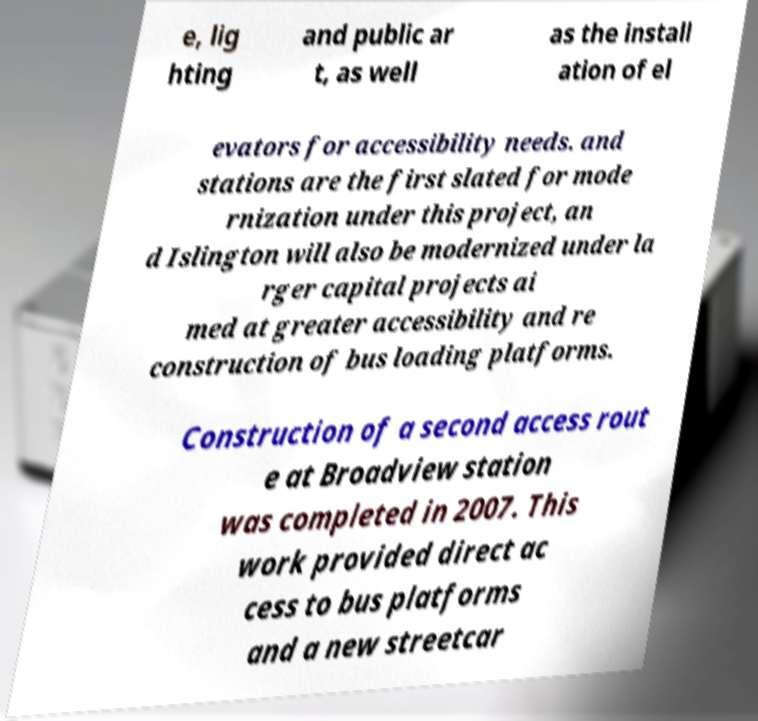Please identify and transcribe the text found in this image. e, lig hting and public ar t, as well as the install ation of el evators for accessibility needs. and stations are the first slated for mode rnization under this project, an d Islington will also be modernized under la rger capital projects ai med at greater accessibility and re construction of bus loading platforms. Construction of a second access rout e at Broadview station was completed in 2007. This work provided direct ac cess to bus platforms and a new streetcar 